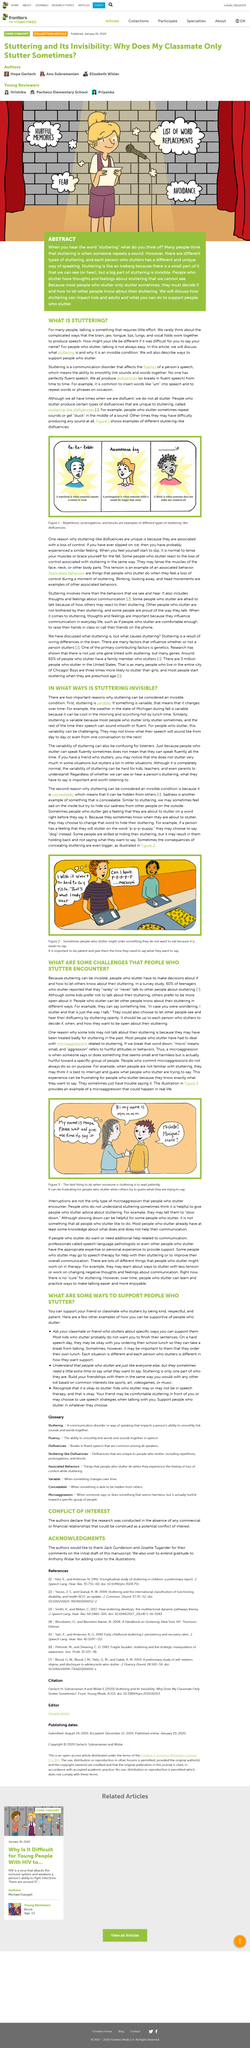Point out several critical features in this image. The title of the article is "What is Stuttering?". This article is about stuttering. The best thing to do when someone is stuttering is to wait patiently. Stuttering may be invisible due to its concealability and variable nature. Concealable means being able to be hidden from others. 